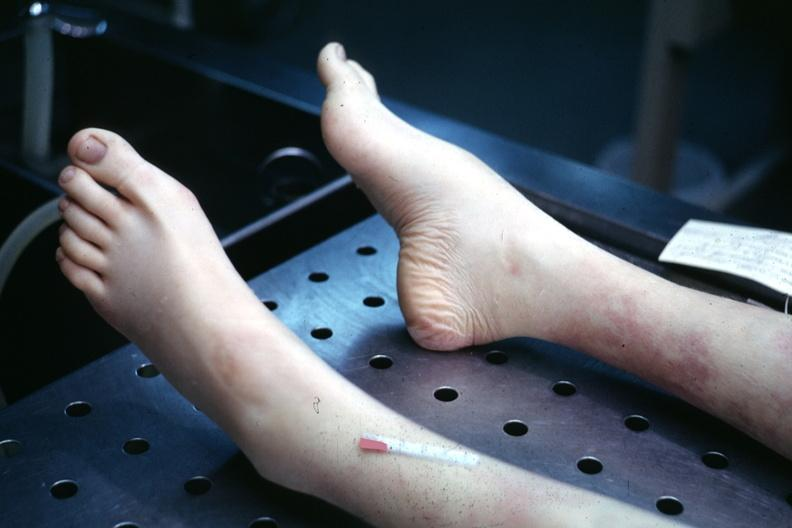what does this image show?
Answer the question using a single word or phrase. 22wf juvenile rheumatoid arthritis mild deformity with high arch 